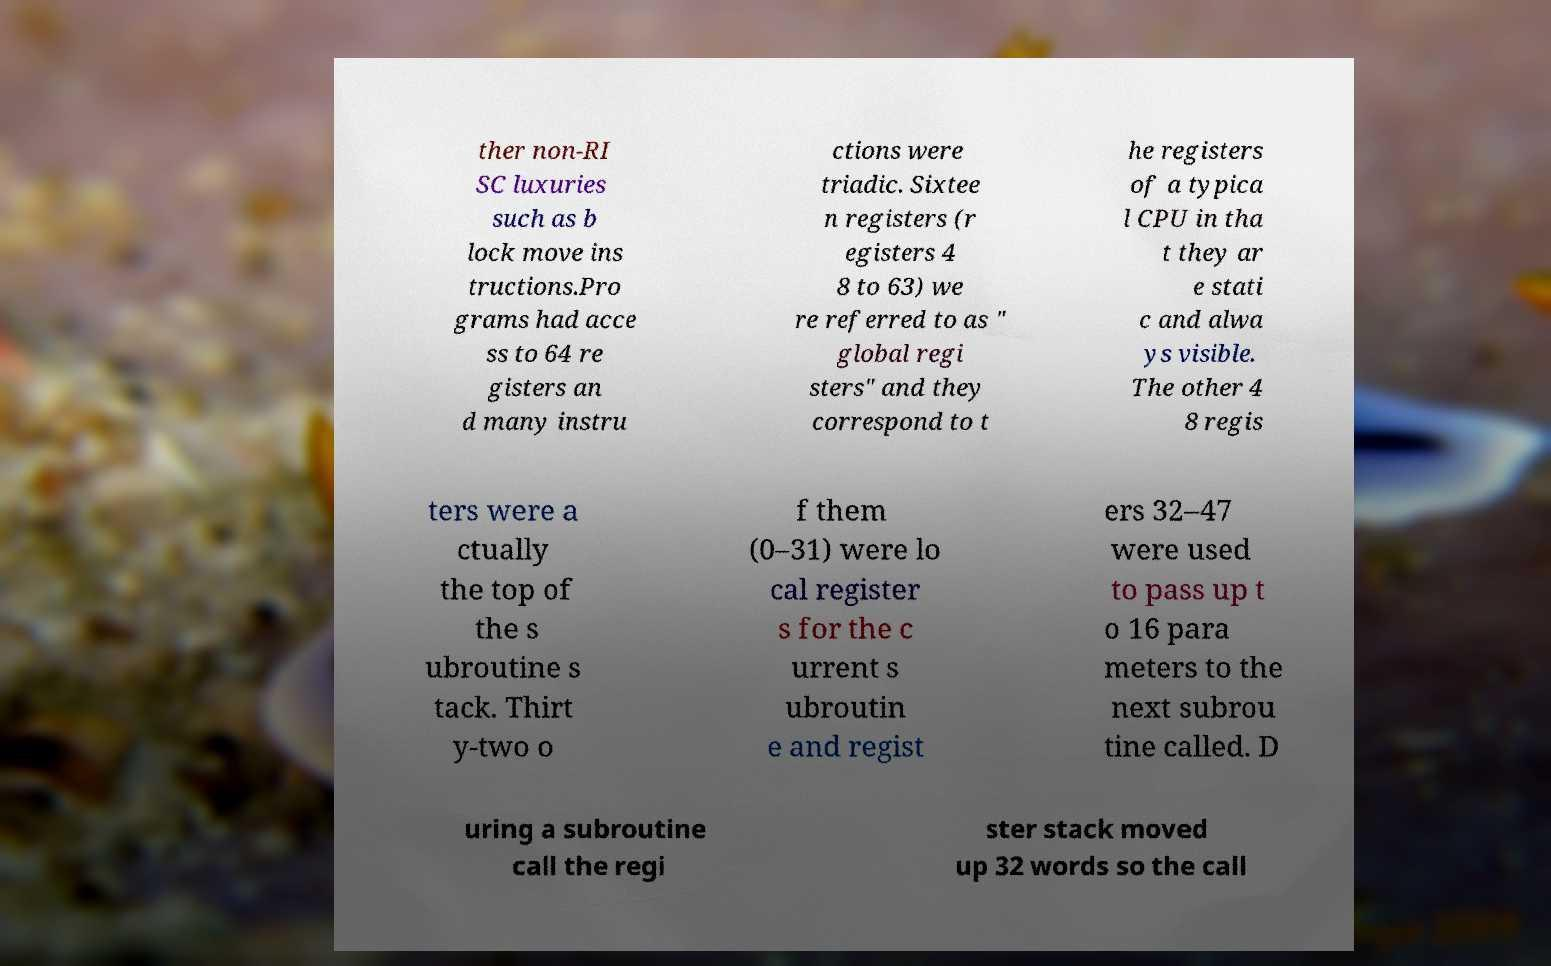Please read and relay the text visible in this image. What does it say? ther non-RI SC luxuries such as b lock move ins tructions.Pro grams had acce ss to 64 re gisters an d many instru ctions were triadic. Sixtee n registers (r egisters 4 8 to 63) we re referred to as " global regi sters" and they correspond to t he registers of a typica l CPU in tha t they ar e stati c and alwa ys visible. The other 4 8 regis ters were a ctually the top of the s ubroutine s tack. Thirt y-two o f them (0–31) were lo cal register s for the c urrent s ubroutin e and regist ers 32–47 were used to pass up t o 16 para meters to the next subrou tine called. D uring a subroutine call the regi ster stack moved up 32 words so the call 